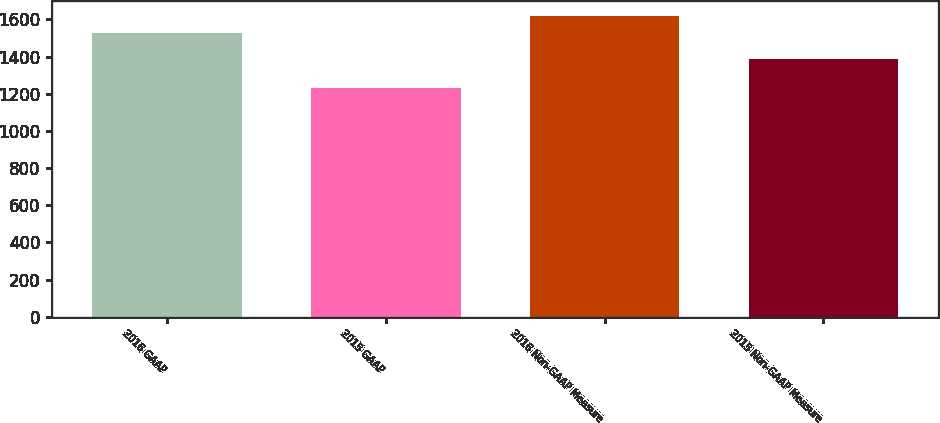Convert chart. <chart><loc_0><loc_0><loc_500><loc_500><bar_chart><fcel>2016 GAAP<fcel>2015 GAAP<fcel>2016 Non-GAAP Measure<fcel>2015 Non-GAAP Measure<nl><fcel>1529.7<fcel>1233.2<fcel>1619.9<fcel>1388.6<nl></chart> 